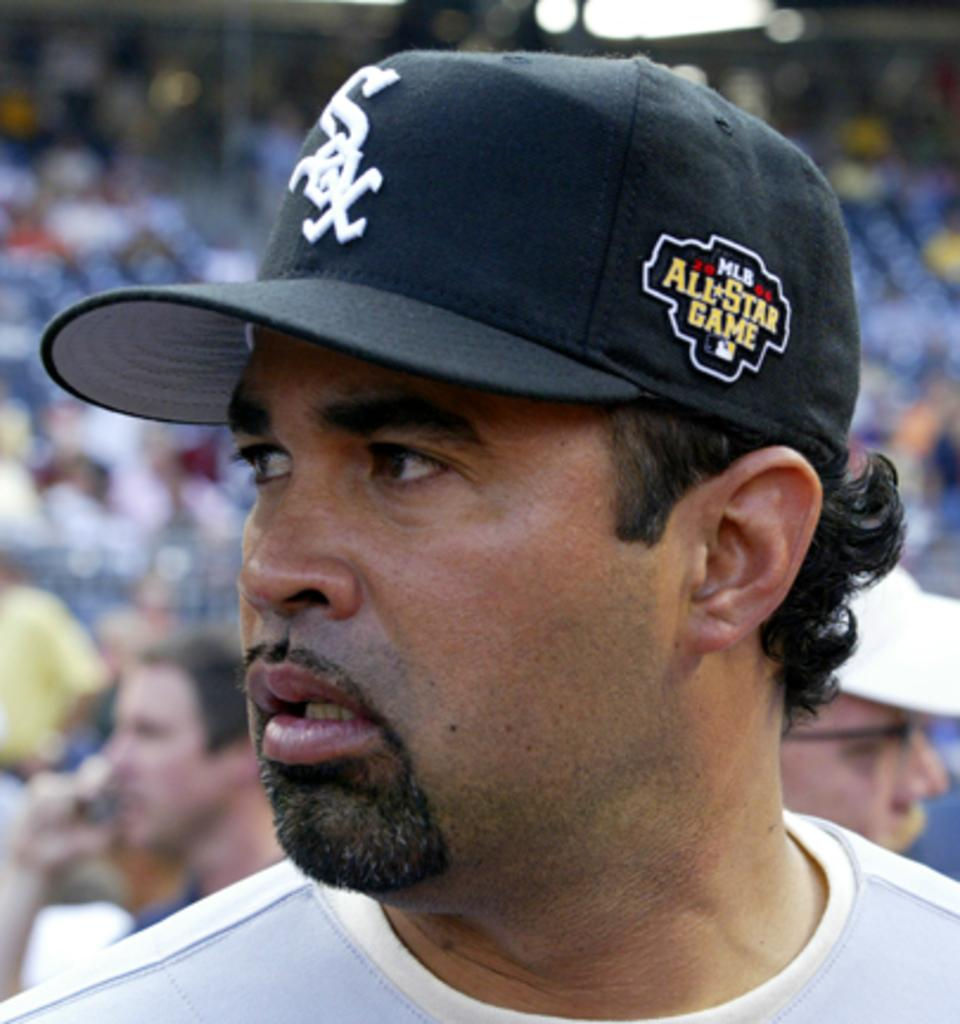Provide a one-sentence caption for the provided image. A hispanic wearing an All Star game sox baseball player looking to the right. 